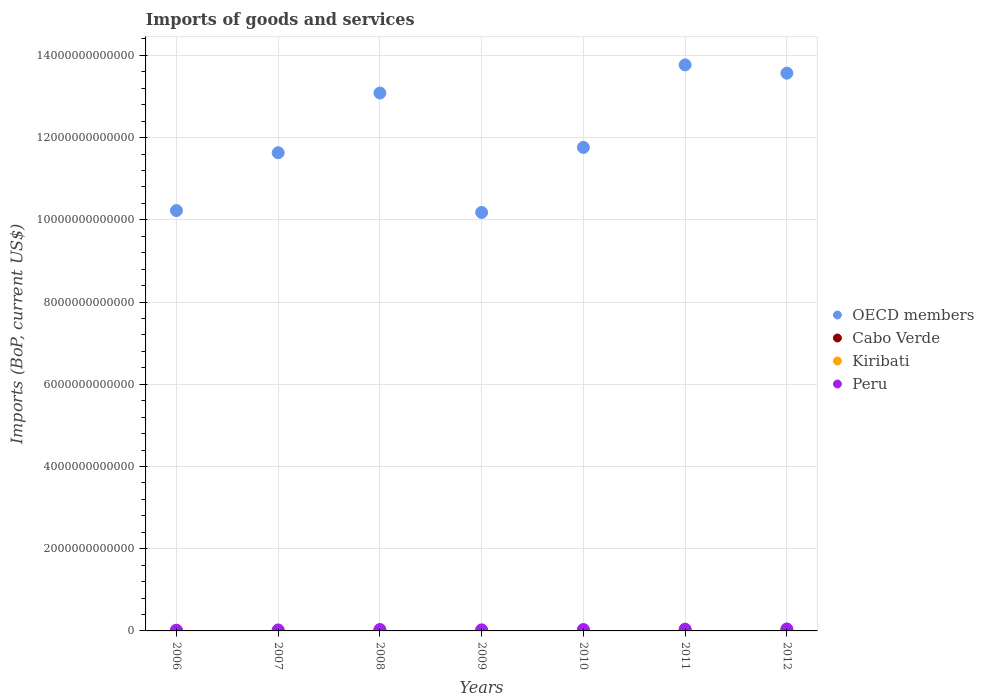Is the number of dotlines equal to the number of legend labels?
Your response must be concise. Yes. What is the amount spent on imports in Peru in 2012?
Offer a terse response. 4.77e+1. Across all years, what is the maximum amount spent on imports in OECD members?
Offer a terse response. 1.38e+13. Across all years, what is the minimum amount spent on imports in Peru?
Your answer should be compact. 1.79e+1. In which year was the amount spent on imports in Peru minimum?
Your answer should be compact. 2006. What is the total amount spent on imports in Kiribati in the graph?
Your answer should be very brief. 9.16e+08. What is the difference between the amount spent on imports in Cabo Verde in 2007 and that in 2010?
Provide a succinct answer. -8.03e+07. What is the difference between the amount spent on imports in Peru in 2010 and the amount spent on imports in OECD members in 2007?
Make the answer very short. -1.16e+13. What is the average amount spent on imports in Cabo Verde per year?
Your answer should be very brief. 1.11e+09. In the year 2010, what is the difference between the amount spent on imports in Cabo Verde and amount spent on imports in Kiribati?
Your response must be concise. 9.88e+08. What is the ratio of the amount spent on imports in OECD members in 2009 to that in 2010?
Provide a short and direct response. 0.87. What is the difference between the highest and the second highest amount spent on imports in OECD members?
Your answer should be compact. 2.02e+11. What is the difference between the highest and the lowest amount spent on imports in Cabo Verde?
Your answer should be compact. 5.70e+08. Is the sum of the amount spent on imports in OECD members in 2007 and 2011 greater than the maximum amount spent on imports in Cabo Verde across all years?
Offer a very short reply. Yes. Is it the case that in every year, the sum of the amount spent on imports in Peru and amount spent on imports in Cabo Verde  is greater than the sum of amount spent on imports in Kiribati and amount spent on imports in OECD members?
Offer a very short reply. Yes. How many dotlines are there?
Give a very brief answer. 4. What is the difference between two consecutive major ticks on the Y-axis?
Provide a short and direct response. 2.00e+12. Are the values on the major ticks of Y-axis written in scientific E-notation?
Keep it short and to the point. No. Does the graph contain any zero values?
Ensure brevity in your answer.  No. Where does the legend appear in the graph?
Make the answer very short. Center right. How are the legend labels stacked?
Your answer should be very brief. Vertical. What is the title of the graph?
Offer a very short reply. Imports of goods and services. What is the label or title of the Y-axis?
Your answer should be very brief. Imports (BoP, current US$). What is the Imports (BoP, current US$) of OECD members in 2006?
Your answer should be compact. 1.02e+13. What is the Imports (BoP, current US$) in Cabo Verde in 2006?
Make the answer very short. 8.04e+08. What is the Imports (BoP, current US$) in Kiribati in 2006?
Offer a very short reply. 9.63e+07. What is the Imports (BoP, current US$) of Peru in 2006?
Make the answer very short. 1.79e+1. What is the Imports (BoP, current US$) in OECD members in 2007?
Your response must be concise. 1.16e+13. What is the Imports (BoP, current US$) of Cabo Verde in 2007?
Your answer should be very brief. 1.03e+09. What is the Imports (BoP, current US$) in Kiribati in 2007?
Your answer should be very brief. 1.16e+08. What is the Imports (BoP, current US$) in Peru in 2007?
Provide a succinct answer. 2.36e+1. What is the Imports (BoP, current US$) in OECD members in 2008?
Your answer should be compact. 1.31e+13. What is the Imports (BoP, current US$) in Cabo Verde in 2008?
Offer a terse response. 1.18e+09. What is the Imports (BoP, current US$) in Kiribati in 2008?
Provide a short and direct response. 1.26e+08. What is the Imports (BoP, current US$) in Peru in 2008?
Make the answer very short. 3.38e+1. What is the Imports (BoP, current US$) of OECD members in 2009?
Ensure brevity in your answer.  1.02e+13. What is the Imports (BoP, current US$) of Cabo Verde in 2009?
Give a very brief answer. 1.08e+09. What is the Imports (BoP, current US$) in Kiribati in 2009?
Offer a terse response. 1.16e+08. What is the Imports (BoP, current US$) in Peru in 2009?
Ensure brevity in your answer.  2.56e+1. What is the Imports (BoP, current US$) in OECD members in 2010?
Your answer should be compact. 1.18e+13. What is the Imports (BoP, current US$) of Cabo Verde in 2010?
Offer a very short reply. 1.11e+09. What is the Imports (BoP, current US$) in Kiribati in 2010?
Provide a short and direct response. 1.26e+08. What is the Imports (BoP, current US$) in Peru in 2010?
Give a very brief answer. 3.44e+1. What is the Imports (BoP, current US$) in OECD members in 2011?
Provide a succinct answer. 1.38e+13. What is the Imports (BoP, current US$) in Cabo Verde in 2011?
Offer a terse response. 1.37e+09. What is the Imports (BoP, current US$) in Kiribati in 2011?
Provide a succinct answer. 1.56e+08. What is the Imports (BoP, current US$) of Peru in 2011?
Your answer should be compact. 4.30e+1. What is the Imports (BoP, current US$) of OECD members in 2012?
Give a very brief answer. 1.36e+13. What is the Imports (BoP, current US$) in Cabo Verde in 2012?
Provide a short and direct response. 1.19e+09. What is the Imports (BoP, current US$) of Kiribati in 2012?
Provide a short and direct response. 1.80e+08. What is the Imports (BoP, current US$) in Peru in 2012?
Offer a terse response. 4.77e+1. Across all years, what is the maximum Imports (BoP, current US$) in OECD members?
Your response must be concise. 1.38e+13. Across all years, what is the maximum Imports (BoP, current US$) in Cabo Verde?
Provide a succinct answer. 1.37e+09. Across all years, what is the maximum Imports (BoP, current US$) of Kiribati?
Give a very brief answer. 1.80e+08. Across all years, what is the maximum Imports (BoP, current US$) of Peru?
Ensure brevity in your answer.  4.77e+1. Across all years, what is the minimum Imports (BoP, current US$) of OECD members?
Keep it short and to the point. 1.02e+13. Across all years, what is the minimum Imports (BoP, current US$) in Cabo Verde?
Offer a very short reply. 8.04e+08. Across all years, what is the minimum Imports (BoP, current US$) in Kiribati?
Provide a succinct answer. 9.63e+07. Across all years, what is the minimum Imports (BoP, current US$) in Peru?
Offer a very short reply. 1.79e+1. What is the total Imports (BoP, current US$) in OECD members in the graph?
Offer a terse response. 8.42e+13. What is the total Imports (BoP, current US$) of Cabo Verde in the graph?
Ensure brevity in your answer.  7.78e+09. What is the total Imports (BoP, current US$) in Kiribati in the graph?
Keep it short and to the point. 9.16e+08. What is the total Imports (BoP, current US$) in Peru in the graph?
Give a very brief answer. 2.26e+11. What is the difference between the Imports (BoP, current US$) in OECD members in 2006 and that in 2007?
Offer a terse response. -1.41e+12. What is the difference between the Imports (BoP, current US$) of Cabo Verde in 2006 and that in 2007?
Provide a short and direct response. -2.30e+08. What is the difference between the Imports (BoP, current US$) of Kiribati in 2006 and that in 2007?
Keep it short and to the point. -1.95e+07. What is the difference between the Imports (BoP, current US$) in Peru in 2006 and that in 2007?
Keep it short and to the point. -5.74e+09. What is the difference between the Imports (BoP, current US$) of OECD members in 2006 and that in 2008?
Provide a short and direct response. -2.86e+12. What is the difference between the Imports (BoP, current US$) in Cabo Verde in 2006 and that in 2008?
Give a very brief answer. -3.79e+08. What is the difference between the Imports (BoP, current US$) in Kiribati in 2006 and that in 2008?
Your answer should be compact. -2.96e+07. What is the difference between the Imports (BoP, current US$) of Peru in 2006 and that in 2008?
Make the answer very short. -1.59e+1. What is the difference between the Imports (BoP, current US$) of OECD members in 2006 and that in 2009?
Your answer should be very brief. 4.54e+1. What is the difference between the Imports (BoP, current US$) in Cabo Verde in 2006 and that in 2009?
Give a very brief answer. -2.79e+08. What is the difference between the Imports (BoP, current US$) in Kiribati in 2006 and that in 2009?
Ensure brevity in your answer.  -1.99e+07. What is the difference between the Imports (BoP, current US$) in Peru in 2006 and that in 2009?
Offer a very short reply. -7.75e+09. What is the difference between the Imports (BoP, current US$) in OECD members in 2006 and that in 2010?
Ensure brevity in your answer.  -1.54e+12. What is the difference between the Imports (BoP, current US$) of Cabo Verde in 2006 and that in 2010?
Offer a terse response. -3.10e+08. What is the difference between the Imports (BoP, current US$) in Kiribati in 2006 and that in 2010?
Offer a terse response. -2.94e+07. What is the difference between the Imports (BoP, current US$) in Peru in 2006 and that in 2010?
Your answer should be compact. -1.66e+1. What is the difference between the Imports (BoP, current US$) in OECD members in 2006 and that in 2011?
Your answer should be compact. -3.54e+12. What is the difference between the Imports (BoP, current US$) in Cabo Verde in 2006 and that in 2011?
Provide a succinct answer. -5.70e+08. What is the difference between the Imports (BoP, current US$) in Kiribati in 2006 and that in 2011?
Your answer should be very brief. -5.98e+07. What is the difference between the Imports (BoP, current US$) in Peru in 2006 and that in 2011?
Ensure brevity in your answer.  -2.51e+1. What is the difference between the Imports (BoP, current US$) of OECD members in 2006 and that in 2012?
Provide a succinct answer. -3.34e+12. What is the difference between the Imports (BoP, current US$) of Cabo Verde in 2006 and that in 2012?
Ensure brevity in your answer.  -3.84e+08. What is the difference between the Imports (BoP, current US$) of Kiribati in 2006 and that in 2012?
Provide a succinct answer. -8.41e+07. What is the difference between the Imports (BoP, current US$) of Peru in 2006 and that in 2012?
Provide a succinct answer. -2.99e+1. What is the difference between the Imports (BoP, current US$) in OECD members in 2007 and that in 2008?
Your answer should be compact. -1.45e+12. What is the difference between the Imports (BoP, current US$) of Cabo Verde in 2007 and that in 2008?
Your answer should be very brief. -1.50e+08. What is the difference between the Imports (BoP, current US$) in Kiribati in 2007 and that in 2008?
Give a very brief answer. -1.01e+07. What is the difference between the Imports (BoP, current US$) in Peru in 2007 and that in 2008?
Your answer should be compact. -1.02e+1. What is the difference between the Imports (BoP, current US$) of OECD members in 2007 and that in 2009?
Ensure brevity in your answer.  1.45e+12. What is the difference between the Imports (BoP, current US$) in Cabo Verde in 2007 and that in 2009?
Keep it short and to the point. -4.92e+07. What is the difference between the Imports (BoP, current US$) in Kiribati in 2007 and that in 2009?
Provide a short and direct response. -4.05e+05. What is the difference between the Imports (BoP, current US$) of Peru in 2007 and that in 2009?
Your response must be concise. -2.01e+09. What is the difference between the Imports (BoP, current US$) of OECD members in 2007 and that in 2010?
Your answer should be compact. -1.30e+11. What is the difference between the Imports (BoP, current US$) in Cabo Verde in 2007 and that in 2010?
Provide a short and direct response. -8.03e+07. What is the difference between the Imports (BoP, current US$) in Kiribati in 2007 and that in 2010?
Ensure brevity in your answer.  -9.92e+06. What is the difference between the Imports (BoP, current US$) of Peru in 2007 and that in 2010?
Offer a very short reply. -1.08e+1. What is the difference between the Imports (BoP, current US$) in OECD members in 2007 and that in 2011?
Your response must be concise. -2.14e+12. What is the difference between the Imports (BoP, current US$) in Cabo Verde in 2007 and that in 2011?
Make the answer very short. -3.40e+08. What is the difference between the Imports (BoP, current US$) in Kiribati in 2007 and that in 2011?
Make the answer very short. -4.03e+07. What is the difference between the Imports (BoP, current US$) in Peru in 2007 and that in 2011?
Give a very brief answer. -1.93e+1. What is the difference between the Imports (BoP, current US$) of OECD members in 2007 and that in 2012?
Offer a terse response. -1.94e+12. What is the difference between the Imports (BoP, current US$) in Cabo Verde in 2007 and that in 2012?
Your answer should be compact. -1.54e+08. What is the difference between the Imports (BoP, current US$) of Kiribati in 2007 and that in 2012?
Ensure brevity in your answer.  -6.46e+07. What is the difference between the Imports (BoP, current US$) of Peru in 2007 and that in 2012?
Your answer should be very brief. -2.41e+1. What is the difference between the Imports (BoP, current US$) in OECD members in 2008 and that in 2009?
Offer a terse response. 2.90e+12. What is the difference between the Imports (BoP, current US$) in Cabo Verde in 2008 and that in 2009?
Provide a succinct answer. 1.00e+08. What is the difference between the Imports (BoP, current US$) in Kiribati in 2008 and that in 2009?
Your answer should be compact. 9.73e+06. What is the difference between the Imports (BoP, current US$) in Peru in 2008 and that in 2009?
Provide a succinct answer. 8.17e+09. What is the difference between the Imports (BoP, current US$) in OECD members in 2008 and that in 2010?
Ensure brevity in your answer.  1.32e+12. What is the difference between the Imports (BoP, current US$) of Cabo Verde in 2008 and that in 2010?
Give a very brief answer. 6.93e+07. What is the difference between the Imports (BoP, current US$) in Kiribati in 2008 and that in 2010?
Your response must be concise. 2.10e+05. What is the difference between the Imports (BoP, current US$) of Peru in 2008 and that in 2010?
Give a very brief answer. -6.41e+08. What is the difference between the Imports (BoP, current US$) of OECD members in 2008 and that in 2011?
Provide a succinct answer. -6.85e+11. What is the difference between the Imports (BoP, current US$) in Cabo Verde in 2008 and that in 2011?
Your response must be concise. -1.90e+08. What is the difference between the Imports (BoP, current US$) in Kiribati in 2008 and that in 2011?
Offer a very short reply. -3.02e+07. What is the difference between the Imports (BoP, current US$) of Peru in 2008 and that in 2011?
Your response must be concise. -9.17e+09. What is the difference between the Imports (BoP, current US$) in OECD members in 2008 and that in 2012?
Make the answer very short. -4.83e+11. What is the difference between the Imports (BoP, current US$) of Cabo Verde in 2008 and that in 2012?
Your answer should be very brief. -4.40e+06. What is the difference between the Imports (BoP, current US$) of Kiribati in 2008 and that in 2012?
Provide a short and direct response. -5.44e+07. What is the difference between the Imports (BoP, current US$) in Peru in 2008 and that in 2012?
Your answer should be very brief. -1.39e+1. What is the difference between the Imports (BoP, current US$) in OECD members in 2009 and that in 2010?
Offer a terse response. -1.58e+12. What is the difference between the Imports (BoP, current US$) in Cabo Verde in 2009 and that in 2010?
Keep it short and to the point. -3.11e+07. What is the difference between the Imports (BoP, current US$) of Kiribati in 2009 and that in 2010?
Provide a short and direct response. -9.52e+06. What is the difference between the Imports (BoP, current US$) of Peru in 2009 and that in 2010?
Your response must be concise. -8.81e+09. What is the difference between the Imports (BoP, current US$) in OECD members in 2009 and that in 2011?
Give a very brief answer. -3.59e+12. What is the difference between the Imports (BoP, current US$) of Cabo Verde in 2009 and that in 2011?
Offer a very short reply. -2.91e+08. What is the difference between the Imports (BoP, current US$) of Kiribati in 2009 and that in 2011?
Ensure brevity in your answer.  -3.99e+07. What is the difference between the Imports (BoP, current US$) in Peru in 2009 and that in 2011?
Keep it short and to the point. -1.73e+1. What is the difference between the Imports (BoP, current US$) in OECD members in 2009 and that in 2012?
Ensure brevity in your answer.  -3.39e+12. What is the difference between the Imports (BoP, current US$) of Cabo Verde in 2009 and that in 2012?
Offer a terse response. -1.05e+08. What is the difference between the Imports (BoP, current US$) in Kiribati in 2009 and that in 2012?
Provide a short and direct response. -6.42e+07. What is the difference between the Imports (BoP, current US$) of Peru in 2009 and that in 2012?
Your answer should be very brief. -2.21e+1. What is the difference between the Imports (BoP, current US$) in OECD members in 2010 and that in 2011?
Your response must be concise. -2.01e+12. What is the difference between the Imports (BoP, current US$) of Cabo Verde in 2010 and that in 2011?
Ensure brevity in your answer.  -2.60e+08. What is the difference between the Imports (BoP, current US$) in Kiribati in 2010 and that in 2011?
Ensure brevity in your answer.  -3.04e+07. What is the difference between the Imports (BoP, current US$) of Peru in 2010 and that in 2011?
Give a very brief answer. -8.53e+09. What is the difference between the Imports (BoP, current US$) in OECD members in 2010 and that in 2012?
Ensure brevity in your answer.  -1.81e+12. What is the difference between the Imports (BoP, current US$) in Cabo Verde in 2010 and that in 2012?
Your answer should be compact. -7.37e+07. What is the difference between the Imports (BoP, current US$) of Kiribati in 2010 and that in 2012?
Keep it short and to the point. -5.46e+07. What is the difference between the Imports (BoP, current US$) of Peru in 2010 and that in 2012?
Give a very brief answer. -1.33e+1. What is the difference between the Imports (BoP, current US$) in OECD members in 2011 and that in 2012?
Provide a short and direct response. 2.02e+11. What is the difference between the Imports (BoP, current US$) in Cabo Verde in 2011 and that in 2012?
Ensure brevity in your answer.  1.86e+08. What is the difference between the Imports (BoP, current US$) of Kiribati in 2011 and that in 2012?
Ensure brevity in your answer.  -2.43e+07. What is the difference between the Imports (BoP, current US$) of Peru in 2011 and that in 2012?
Your answer should be very brief. -4.77e+09. What is the difference between the Imports (BoP, current US$) in OECD members in 2006 and the Imports (BoP, current US$) in Cabo Verde in 2007?
Offer a very short reply. 1.02e+13. What is the difference between the Imports (BoP, current US$) in OECD members in 2006 and the Imports (BoP, current US$) in Kiribati in 2007?
Your answer should be very brief. 1.02e+13. What is the difference between the Imports (BoP, current US$) in OECD members in 2006 and the Imports (BoP, current US$) in Peru in 2007?
Keep it short and to the point. 1.02e+13. What is the difference between the Imports (BoP, current US$) in Cabo Verde in 2006 and the Imports (BoP, current US$) in Kiribati in 2007?
Provide a short and direct response. 6.88e+08. What is the difference between the Imports (BoP, current US$) in Cabo Verde in 2006 and the Imports (BoP, current US$) in Peru in 2007?
Provide a short and direct response. -2.28e+1. What is the difference between the Imports (BoP, current US$) in Kiribati in 2006 and the Imports (BoP, current US$) in Peru in 2007?
Your answer should be very brief. -2.35e+1. What is the difference between the Imports (BoP, current US$) of OECD members in 2006 and the Imports (BoP, current US$) of Cabo Verde in 2008?
Your answer should be compact. 1.02e+13. What is the difference between the Imports (BoP, current US$) in OECD members in 2006 and the Imports (BoP, current US$) in Kiribati in 2008?
Provide a short and direct response. 1.02e+13. What is the difference between the Imports (BoP, current US$) in OECD members in 2006 and the Imports (BoP, current US$) in Peru in 2008?
Offer a terse response. 1.02e+13. What is the difference between the Imports (BoP, current US$) of Cabo Verde in 2006 and the Imports (BoP, current US$) of Kiribati in 2008?
Offer a very short reply. 6.78e+08. What is the difference between the Imports (BoP, current US$) in Cabo Verde in 2006 and the Imports (BoP, current US$) in Peru in 2008?
Keep it short and to the point. -3.30e+1. What is the difference between the Imports (BoP, current US$) in Kiribati in 2006 and the Imports (BoP, current US$) in Peru in 2008?
Offer a terse response. -3.37e+1. What is the difference between the Imports (BoP, current US$) in OECD members in 2006 and the Imports (BoP, current US$) in Cabo Verde in 2009?
Your answer should be compact. 1.02e+13. What is the difference between the Imports (BoP, current US$) in OECD members in 2006 and the Imports (BoP, current US$) in Kiribati in 2009?
Your answer should be compact. 1.02e+13. What is the difference between the Imports (BoP, current US$) of OECD members in 2006 and the Imports (BoP, current US$) of Peru in 2009?
Your answer should be very brief. 1.02e+13. What is the difference between the Imports (BoP, current US$) of Cabo Verde in 2006 and the Imports (BoP, current US$) of Kiribati in 2009?
Keep it short and to the point. 6.88e+08. What is the difference between the Imports (BoP, current US$) in Cabo Verde in 2006 and the Imports (BoP, current US$) in Peru in 2009?
Offer a terse response. -2.48e+1. What is the difference between the Imports (BoP, current US$) in Kiribati in 2006 and the Imports (BoP, current US$) in Peru in 2009?
Your answer should be very brief. -2.55e+1. What is the difference between the Imports (BoP, current US$) of OECD members in 2006 and the Imports (BoP, current US$) of Cabo Verde in 2010?
Ensure brevity in your answer.  1.02e+13. What is the difference between the Imports (BoP, current US$) of OECD members in 2006 and the Imports (BoP, current US$) of Kiribati in 2010?
Your answer should be compact. 1.02e+13. What is the difference between the Imports (BoP, current US$) in OECD members in 2006 and the Imports (BoP, current US$) in Peru in 2010?
Give a very brief answer. 1.02e+13. What is the difference between the Imports (BoP, current US$) of Cabo Verde in 2006 and the Imports (BoP, current US$) of Kiribati in 2010?
Make the answer very short. 6.78e+08. What is the difference between the Imports (BoP, current US$) in Cabo Verde in 2006 and the Imports (BoP, current US$) in Peru in 2010?
Provide a succinct answer. -3.36e+1. What is the difference between the Imports (BoP, current US$) of Kiribati in 2006 and the Imports (BoP, current US$) of Peru in 2010?
Offer a terse response. -3.43e+1. What is the difference between the Imports (BoP, current US$) in OECD members in 2006 and the Imports (BoP, current US$) in Cabo Verde in 2011?
Provide a succinct answer. 1.02e+13. What is the difference between the Imports (BoP, current US$) of OECD members in 2006 and the Imports (BoP, current US$) of Kiribati in 2011?
Give a very brief answer. 1.02e+13. What is the difference between the Imports (BoP, current US$) of OECD members in 2006 and the Imports (BoP, current US$) of Peru in 2011?
Ensure brevity in your answer.  1.02e+13. What is the difference between the Imports (BoP, current US$) in Cabo Verde in 2006 and the Imports (BoP, current US$) in Kiribati in 2011?
Your answer should be compact. 6.48e+08. What is the difference between the Imports (BoP, current US$) of Cabo Verde in 2006 and the Imports (BoP, current US$) of Peru in 2011?
Your response must be concise. -4.22e+1. What is the difference between the Imports (BoP, current US$) of Kiribati in 2006 and the Imports (BoP, current US$) of Peru in 2011?
Your answer should be compact. -4.29e+1. What is the difference between the Imports (BoP, current US$) in OECD members in 2006 and the Imports (BoP, current US$) in Cabo Verde in 2012?
Offer a very short reply. 1.02e+13. What is the difference between the Imports (BoP, current US$) in OECD members in 2006 and the Imports (BoP, current US$) in Kiribati in 2012?
Ensure brevity in your answer.  1.02e+13. What is the difference between the Imports (BoP, current US$) in OECD members in 2006 and the Imports (BoP, current US$) in Peru in 2012?
Give a very brief answer. 1.02e+13. What is the difference between the Imports (BoP, current US$) in Cabo Verde in 2006 and the Imports (BoP, current US$) in Kiribati in 2012?
Your answer should be very brief. 6.23e+08. What is the difference between the Imports (BoP, current US$) of Cabo Verde in 2006 and the Imports (BoP, current US$) of Peru in 2012?
Your answer should be very brief. -4.69e+1. What is the difference between the Imports (BoP, current US$) in Kiribati in 2006 and the Imports (BoP, current US$) in Peru in 2012?
Provide a short and direct response. -4.76e+1. What is the difference between the Imports (BoP, current US$) of OECD members in 2007 and the Imports (BoP, current US$) of Cabo Verde in 2008?
Your response must be concise. 1.16e+13. What is the difference between the Imports (BoP, current US$) in OECD members in 2007 and the Imports (BoP, current US$) in Kiribati in 2008?
Your response must be concise. 1.16e+13. What is the difference between the Imports (BoP, current US$) of OECD members in 2007 and the Imports (BoP, current US$) of Peru in 2008?
Offer a very short reply. 1.16e+13. What is the difference between the Imports (BoP, current US$) in Cabo Verde in 2007 and the Imports (BoP, current US$) in Kiribati in 2008?
Give a very brief answer. 9.08e+08. What is the difference between the Imports (BoP, current US$) in Cabo Verde in 2007 and the Imports (BoP, current US$) in Peru in 2008?
Keep it short and to the point. -3.28e+1. What is the difference between the Imports (BoP, current US$) in Kiribati in 2007 and the Imports (BoP, current US$) in Peru in 2008?
Keep it short and to the point. -3.37e+1. What is the difference between the Imports (BoP, current US$) in OECD members in 2007 and the Imports (BoP, current US$) in Cabo Verde in 2009?
Your response must be concise. 1.16e+13. What is the difference between the Imports (BoP, current US$) of OECD members in 2007 and the Imports (BoP, current US$) of Kiribati in 2009?
Provide a short and direct response. 1.16e+13. What is the difference between the Imports (BoP, current US$) in OECD members in 2007 and the Imports (BoP, current US$) in Peru in 2009?
Provide a succinct answer. 1.16e+13. What is the difference between the Imports (BoP, current US$) in Cabo Verde in 2007 and the Imports (BoP, current US$) in Kiribati in 2009?
Give a very brief answer. 9.17e+08. What is the difference between the Imports (BoP, current US$) of Cabo Verde in 2007 and the Imports (BoP, current US$) of Peru in 2009?
Your answer should be compact. -2.46e+1. What is the difference between the Imports (BoP, current US$) in Kiribati in 2007 and the Imports (BoP, current US$) in Peru in 2009?
Keep it short and to the point. -2.55e+1. What is the difference between the Imports (BoP, current US$) of OECD members in 2007 and the Imports (BoP, current US$) of Cabo Verde in 2010?
Keep it short and to the point. 1.16e+13. What is the difference between the Imports (BoP, current US$) of OECD members in 2007 and the Imports (BoP, current US$) of Kiribati in 2010?
Provide a short and direct response. 1.16e+13. What is the difference between the Imports (BoP, current US$) of OECD members in 2007 and the Imports (BoP, current US$) of Peru in 2010?
Your answer should be compact. 1.16e+13. What is the difference between the Imports (BoP, current US$) in Cabo Verde in 2007 and the Imports (BoP, current US$) in Kiribati in 2010?
Provide a succinct answer. 9.08e+08. What is the difference between the Imports (BoP, current US$) of Cabo Verde in 2007 and the Imports (BoP, current US$) of Peru in 2010?
Keep it short and to the point. -3.34e+1. What is the difference between the Imports (BoP, current US$) in Kiribati in 2007 and the Imports (BoP, current US$) in Peru in 2010?
Offer a very short reply. -3.43e+1. What is the difference between the Imports (BoP, current US$) of OECD members in 2007 and the Imports (BoP, current US$) of Cabo Verde in 2011?
Your response must be concise. 1.16e+13. What is the difference between the Imports (BoP, current US$) of OECD members in 2007 and the Imports (BoP, current US$) of Kiribati in 2011?
Your response must be concise. 1.16e+13. What is the difference between the Imports (BoP, current US$) of OECD members in 2007 and the Imports (BoP, current US$) of Peru in 2011?
Your answer should be very brief. 1.16e+13. What is the difference between the Imports (BoP, current US$) in Cabo Verde in 2007 and the Imports (BoP, current US$) in Kiribati in 2011?
Provide a short and direct response. 8.77e+08. What is the difference between the Imports (BoP, current US$) of Cabo Verde in 2007 and the Imports (BoP, current US$) of Peru in 2011?
Make the answer very short. -4.19e+1. What is the difference between the Imports (BoP, current US$) in Kiribati in 2007 and the Imports (BoP, current US$) in Peru in 2011?
Offer a terse response. -4.28e+1. What is the difference between the Imports (BoP, current US$) in OECD members in 2007 and the Imports (BoP, current US$) in Cabo Verde in 2012?
Keep it short and to the point. 1.16e+13. What is the difference between the Imports (BoP, current US$) of OECD members in 2007 and the Imports (BoP, current US$) of Kiribati in 2012?
Give a very brief answer. 1.16e+13. What is the difference between the Imports (BoP, current US$) of OECD members in 2007 and the Imports (BoP, current US$) of Peru in 2012?
Make the answer very short. 1.16e+13. What is the difference between the Imports (BoP, current US$) of Cabo Verde in 2007 and the Imports (BoP, current US$) of Kiribati in 2012?
Make the answer very short. 8.53e+08. What is the difference between the Imports (BoP, current US$) of Cabo Verde in 2007 and the Imports (BoP, current US$) of Peru in 2012?
Offer a terse response. -4.67e+1. What is the difference between the Imports (BoP, current US$) of Kiribati in 2007 and the Imports (BoP, current US$) of Peru in 2012?
Provide a succinct answer. -4.76e+1. What is the difference between the Imports (BoP, current US$) in OECD members in 2008 and the Imports (BoP, current US$) in Cabo Verde in 2009?
Ensure brevity in your answer.  1.31e+13. What is the difference between the Imports (BoP, current US$) in OECD members in 2008 and the Imports (BoP, current US$) in Kiribati in 2009?
Provide a short and direct response. 1.31e+13. What is the difference between the Imports (BoP, current US$) in OECD members in 2008 and the Imports (BoP, current US$) in Peru in 2009?
Keep it short and to the point. 1.31e+13. What is the difference between the Imports (BoP, current US$) of Cabo Verde in 2008 and the Imports (BoP, current US$) of Kiribati in 2009?
Your answer should be very brief. 1.07e+09. What is the difference between the Imports (BoP, current US$) of Cabo Verde in 2008 and the Imports (BoP, current US$) of Peru in 2009?
Your answer should be compact. -2.44e+1. What is the difference between the Imports (BoP, current US$) in Kiribati in 2008 and the Imports (BoP, current US$) in Peru in 2009?
Offer a very short reply. -2.55e+1. What is the difference between the Imports (BoP, current US$) of OECD members in 2008 and the Imports (BoP, current US$) of Cabo Verde in 2010?
Your response must be concise. 1.31e+13. What is the difference between the Imports (BoP, current US$) in OECD members in 2008 and the Imports (BoP, current US$) in Kiribati in 2010?
Offer a very short reply. 1.31e+13. What is the difference between the Imports (BoP, current US$) of OECD members in 2008 and the Imports (BoP, current US$) of Peru in 2010?
Give a very brief answer. 1.31e+13. What is the difference between the Imports (BoP, current US$) in Cabo Verde in 2008 and the Imports (BoP, current US$) in Kiribati in 2010?
Offer a terse response. 1.06e+09. What is the difference between the Imports (BoP, current US$) in Cabo Verde in 2008 and the Imports (BoP, current US$) in Peru in 2010?
Your response must be concise. -3.33e+1. What is the difference between the Imports (BoP, current US$) in Kiribati in 2008 and the Imports (BoP, current US$) in Peru in 2010?
Provide a succinct answer. -3.43e+1. What is the difference between the Imports (BoP, current US$) in OECD members in 2008 and the Imports (BoP, current US$) in Cabo Verde in 2011?
Ensure brevity in your answer.  1.31e+13. What is the difference between the Imports (BoP, current US$) of OECD members in 2008 and the Imports (BoP, current US$) of Kiribati in 2011?
Your answer should be compact. 1.31e+13. What is the difference between the Imports (BoP, current US$) in OECD members in 2008 and the Imports (BoP, current US$) in Peru in 2011?
Your response must be concise. 1.30e+13. What is the difference between the Imports (BoP, current US$) of Cabo Verde in 2008 and the Imports (BoP, current US$) of Kiribati in 2011?
Your answer should be very brief. 1.03e+09. What is the difference between the Imports (BoP, current US$) of Cabo Verde in 2008 and the Imports (BoP, current US$) of Peru in 2011?
Give a very brief answer. -4.18e+1. What is the difference between the Imports (BoP, current US$) in Kiribati in 2008 and the Imports (BoP, current US$) in Peru in 2011?
Your response must be concise. -4.28e+1. What is the difference between the Imports (BoP, current US$) in OECD members in 2008 and the Imports (BoP, current US$) in Cabo Verde in 2012?
Offer a very short reply. 1.31e+13. What is the difference between the Imports (BoP, current US$) of OECD members in 2008 and the Imports (BoP, current US$) of Kiribati in 2012?
Your answer should be compact. 1.31e+13. What is the difference between the Imports (BoP, current US$) in OECD members in 2008 and the Imports (BoP, current US$) in Peru in 2012?
Keep it short and to the point. 1.30e+13. What is the difference between the Imports (BoP, current US$) of Cabo Verde in 2008 and the Imports (BoP, current US$) of Kiribati in 2012?
Provide a short and direct response. 1.00e+09. What is the difference between the Imports (BoP, current US$) in Cabo Verde in 2008 and the Imports (BoP, current US$) in Peru in 2012?
Make the answer very short. -4.66e+1. What is the difference between the Imports (BoP, current US$) of Kiribati in 2008 and the Imports (BoP, current US$) of Peru in 2012?
Offer a very short reply. -4.76e+1. What is the difference between the Imports (BoP, current US$) of OECD members in 2009 and the Imports (BoP, current US$) of Cabo Verde in 2010?
Make the answer very short. 1.02e+13. What is the difference between the Imports (BoP, current US$) of OECD members in 2009 and the Imports (BoP, current US$) of Kiribati in 2010?
Your response must be concise. 1.02e+13. What is the difference between the Imports (BoP, current US$) in OECD members in 2009 and the Imports (BoP, current US$) in Peru in 2010?
Offer a very short reply. 1.01e+13. What is the difference between the Imports (BoP, current US$) in Cabo Verde in 2009 and the Imports (BoP, current US$) in Kiribati in 2010?
Offer a terse response. 9.57e+08. What is the difference between the Imports (BoP, current US$) of Cabo Verde in 2009 and the Imports (BoP, current US$) of Peru in 2010?
Provide a short and direct response. -3.34e+1. What is the difference between the Imports (BoP, current US$) of Kiribati in 2009 and the Imports (BoP, current US$) of Peru in 2010?
Keep it short and to the point. -3.43e+1. What is the difference between the Imports (BoP, current US$) of OECD members in 2009 and the Imports (BoP, current US$) of Cabo Verde in 2011?
Your answer should be very brief. 1.02e+13. What is the difference between the Imports (BoP, current US$) in OECD members in 2009 and the Imports (BoP, current US$) in Kiribati in 2011?
Ensure brevity in your answer.  1.02e+13. What is the difference between the Imports (BoP, current US$) in OECD members in 2009 and the Imports (BoP, current US$) in Peru in 2011?
Make the answer very short. 1.01e+13. What is the difference between the Imports (BoP, current US$) in Cabo Verde in 2009 and the Imports (BoP, current US$) in Kiribati in 2011?
Provide a succinct answer. 9.27e+08. What is the difference between the Imports (BoP, current US$) of Cabo Verde in 2009 and the Imports (BoP, current US$) of Peru in 2011?
Provide a succinct answer. -4.19e+1. What is the difference between the Imports (BoP, current US$) in Kiribati in 2009 and the Imports (BoP, current US$) in Peru in 2011?
Give a very brief answer. -4.28e+1. What is the difference between the Imports (BoP, current US$) in OECD members in 2009 and the Imports (BoP, current US$) in Cabo Verde in 2012?
Provide a succinct answer. 1.02e+13. What is the difference between the Imports (BoP, current US$) in OECD members in 2009 and the Imports (BoP, current US$) in Kiribati in 2012?
Ensure brevity in your answer.  1.02e+13. What is the difference between the Imports (BoP, current US$) of OECD members in 2009 and the Imports (BoP, current US$) of Peru in 2012?
Ensure brevity in your answer.  1.01e+13. What is the difference between the Imports (BoP, current US$) in Cabo Verde in 2009 and the Imports (BoP, current US$) in Kiribati in 2012?
Your response must be concise. 9.02e+08. What is the difference between the Imports (BoP, current US$) of Cabo Verde in 2009 and the Imports (BoP, current US$) of Peru in 2012?
Your response must be concise. -4.67e+1. What is the difference between the Imports (BoP, current US$) in Kiribati in 2009 and the Imports (BoP, current US$) in Peru in 2012?
Provide a short and direct response. -4.76e+1. What is the difference between the Imports (BoP, current US$) of OECD members in 2010 and the Imports (BoP, current US$) of Cabo Verde in 2011?
Offer a very short reply. 1.18e+13. What is the difference between the Imports (BoP, current US$) of OECD members in 2010 and the Imports (BoP, current US$) of Kiribati in 2011?
Make the answer very short. 1.18e+13. What is the difference between the Imports (BoP, current US$) of OECD members in 2010 and the Imports (BoP, current US$) of Peru in 2011?
Offer a very short reply. 1.17e+13. What is the difference between the Imports (BoP, current US$) of Cabo Verde in 2010 and the Imports (BoP, current US$) of Kiribati in 2011?
Offer a very short reply. 9.58e+08. What is the difference between the Imports (BoP, current US$) in Cabo Verde in 2010 and the Imports (BoP, current US$) in Peru in 2011?
Provide a succinct answer. -4.18e+1. What is the difference between the Imports (BoP, current US$) in Kiribati in 2010 and the Imports (BoP, current US$) in Peru in 2011?
Make the answer very short. -4.28e+1. What is the difference between the Imports (BoP, current US$) of OECD members in 2010 and the Imports (BoP, current US$) of Cabo Verde in 2012?
Ensure brevity in your answer.  1.18e+13. What is the difference between the Imports (BoP, current US$) in OECD members in 2010 and the Imports (BoP, current US$) in Kiribati in 2012?
Provide a short and direct response. 1.18e+13. What is the difference between the Imports (BoP, current US$) of OECD members in 2010 and the Imports (BoP, current US$) of Peru in 2012?
Offer a very short reply. 1.17e+13. What is the difference between the Imports (BoP, current US$) of Cabo Verde in 2010 and the Imports (BoP, current US$) of Kiribati in 2012?
Provide a succinct answer. 9.33e+08. What is the difference between the Imports (BoP, current US$) in Cabo Verde in 2010 and the Imports (BoP, current US$) in Peru in 2012?
Offer a very short reply. -4.66e+1. What is the difference between the Imports (BoP, current US$) of Kiribati in 2010 and the Imports (BoP, current US$) of Peru in 2012?
Offer a terse response. -4.76e+1. What is the difference between the Imports (BoP, current US$) in OECD members in 2011 and the Imports (BoP, current US$) in Cabo Verde in 2012?
Your response must be concise. 1.38e+13. What is the difference between the Imports (BoP, current US$) of OECD members in 2011 and the Imports (BoP, current US$) of Kiribati in 2012?
Make the answer very short. 1.38e+13. What is the difference between the Imports (BoP, current US$) in OECD members in 2011 and the Imports (BoP, current US$) in Peru in 2012?
Offer a terse response. 1.37e+13. What is the difference between the Imports (BoP, current US$) in Cabo Verde in 2011 and the Imports (BoP, current US$) in Kiribati in 2012?
Make the answer very short. 1.19e+09. What is the difference between the Imports (BoP, current US$) in Cabo Verde in 2011 and the Imports (BoP, current US$) in Peru in 2012?
Ensure brevity in your answer.  -4.64e+1. What is the difference between the Imports (BoP, current US$) in Kiribati in 2011 and the Imports (BoP, current US$) in Peru in 2012?
Ensure brevity in your answer.  -4.76e+1. What is the average Imports (BoP, current US$) of OECD members per year?
Your answer should be compact. 1.20e+13. What is the average Imports (BoP, current US$) of Cabo Verde per year?
Your answer should be very brief. 1.11e+09. What is the average Imports (BoP, current US$) in Kiribati per year?
Offer a terse response. 1.31e+08. What is the average Imports (BoP, current US$) in Peru per year?
Your response must be concise. 3.23e+1. In the year 2006, what is the difference between the Imports (BoP, current US$) of OECD members and Imports (BoP, current US$) of Cabo Verde?
Your answer should be compact. 1.02e+13. In the year 2006, what is the difference between the Imports (BoP, current US$) of OECD members and Imports (BoP, current US$) of Kiribati?
Your answer should be very brief. 1.02e+13. In the year 2006, what is the difference between the Imports (BoP, current US$) in OECD members and Imports (BoP, current US$) in Peru?
Provide a succinct answer. 1.02e+13. In the year 2006, what is the difference between the Imports (BoP, current US$) of Cabo Verde and Imports (BoP, current US$) of Kiribati?
Provide a succinct answer. 7.08e+08. In the year 2006, what is the difference between the Imports (BoP, current US$) of Cabo Verde and Imports (BoP, current US$) of Peru?
Give a very brief answer. -1.71e+1. In the year 2006, what is the difference between the Imports (BoP, current US$) of Kiribati and Imports (BoP, current US$) of Peru?
Offer a terse response. -1.78e+1. In the year 2007, what is the difference between the Imports (BoP, current US$) in OECD members and Imports (BoP, current US$) in Cabo Verde?
Ensure brevity in your answer.  1.16e+13. In the year 2007, what is the difference between the Imports (BoP, current US$) in OECD members and Imports (BoP, current US$) in Kiribati?
Provide a succinct answer. 1.16e+13. In the year 2007, what is the difference between the Imports (BoP, current US$) in OECD members and Imports (BoP, current US$) in Peru?
Ensure brevity in your answer.  1.16e+13. In the year 2007, what is the difference between the Imports (BoP, current US$) of Cabo Verde and Imports (BoP, current US$) of Kiribati?
Keep it short and to the point. 9.18e+08. In the year 2007, what is the difference between the Imports (BoP, current US$) of Cabo Verde and Imports (BoP, current US$) of Peru?
Make the answer very short. -2.26e+1. In the year 2007, what is the difference between the Imports (BoP, current US$) of Kiribati and Imports (BoP, current US$) of Peru?
Offer a terse response. -2.35e+1. In the year 2008, what is the difference between the Imports (BoP, current US$) of OECD members and Imports (BoP, current US$) of Cabo Verde?
Your response must be concise. 1.31e+13. In the year 2008, what is the difference between the Imports (BoP, current US$) in OECD members and Imports (BoP, current US$) in Kiribati?
Give a very brief answer. 1.31e+13. In the year 2008, what is the difference between the Imports (BoP, current US$) in OECD members and Imports (BoP, current US$) in Peru?
Offer a terse response. 1.31e+13. In the year 2008, what is the difference between the Imports (BoP, current US$) in Cabo Verde and Imports (BoP, current US$) in Kiribati?
Your answer should be compact. 1.06e+09. In the year 2008, what is the difference between the Imports (BoP, current US$) in Cabo Verde and Imports (BoP, current US$) in Peru?
Make the answer very short. -3.26e+1. In the year 2008, what is the difference between the Imports (BoP, current US$) of Kiribati and Imports (BoP, current US$) of Peru?
Give a very brief answer. -3.37e+1. In the year 2009, what is the difference between the Imports (BoP, current US$) of OECD members and Imports (BoP, current US$) of Cabo Verde?
Give a very brief answer. 1.02e+13. In the year 2009, what is the difference between the Imports (BoP, current US$) in OECD members and Imports (BoP, current US$) in Kiribati?
Offer a very short reply. 1.02e+13. In the year 2009, what is the difference between the Imports (BoP, current US$) of OECD members and Imports (BoP, current US$) of Peru?
Offer a very short reply. 1.02e+13. In the year 2009, what is the difference between the Imports (BoP, current US$) in Cabo Verde and Imports (BoP, current US$) in Kiribati?
Give a very brief answer. 9.67e+08. In the year 2009, what is the difference between the Imports (BoP, current US$) of Cabo Verde and Imports (BoP, current US$) of Peru?
Give a very brief answer. -2.45e+1. In the year 2009, what is the difference between the Imports (BoP, current US$) of Kiribati and Imports (BoP, current US$) of Peru?
Offer a terse response. -2.55e+1. In the year 2010, what is the difference between the Imports (BoP, current US$) in OECD members and Imports (BoP, current US$) in Cabo Verde?
Ensure brevity in your answer.  1.18e+13. In the year 2010, what is the difference between the Imports (BoP, current US$) of OECD members and Imports (BoP, current US$) of Kiribati?
Your response must be concise. 1.18e+13. In the year 2010, what is the difference between the Imports (BoP, current US$) in OECD members and Imports (BoP, current US$) in Peru?
Offer a very short reply. 1.17e+13. In the year 2010, what is the difference between the Imports (BoP, current US$) of Cabo Verde and Imports (BoP, current US$) of Kiribati?
Make the answer very short. 9.88e+08. In the year 2010, what is the difference between the Imports (BoP, current US$) of Cabo Verde and Imports (BoP, current US$) of Peru?
Your response must be concise. -3.33e+1. In the year 2010, what is the difference between the Imports (BoP, current US$) of Kiribati and Imports (BoP, current US$) of Peru?
Offer a terse response. -3.43e+1. In the year 2011, what is the difference between the Imports (BoP, current US$) of OECD members and Imports (BoP, current US$) of Cabo Verde?
Make the answer very short. 1.38e+13. In the year 2011, what is the difference between the Imports (BoP, current US$) in OECD members and Imports (BoP, current US$) in Kiribati?
Make the answer very short. 1.38e+13. In the year 2011, what is the difference between the Imports (BoP, current US$) of OECD members and Imports (BoP, current US$) of Peru?
Your response must be concise. 1.37e+13. In the year 2011, what is the difference between the Imports (BoP, current US$) of Cabo Verde and Imports (BoP, current US$) of Kiribati?
Give a very brief answer. 1.22e+09. In the year 2011, what is the difference between the Imports (BoP, current US$) of Cabo Verde and Imports (BoP, current US$) of Peru?
Provide a succinct answer. -4.16e+1. In the year 2011, what is the difference between the Imports (BoP, current US$) in Kiribati and Imports (BoP, current US$) in Peru?
Keep it short and to the point. -4.28e+1. In the year 2012, what is the difference between the Imports (BoP, current US$) of OECD members and Imports (BoP, current US$) of Cabo Verde?
Your response must be concise. 1.36e+13. In the year 2012, what is the difference between the Imports (BoP, current US$) of OECD members and Imports (BoP, current US$) of Kiribati?
Your response must be concise. 1.36e+13. In the year 2012, what is the difference between the Imports (BoP, current US$) in OECD members and Imports (BoP, current US$) in Peru?
Provide a short and direct response. 1.35e+13. In the year 2012, what is the difference between the Imports (BoP, current US$) of Cabo Verde and Imports (BoP, current US$) of Kiribati?
Make the answer very short. 1.01e+09. In the year 2012, what is the difference between the Imports (BoP, current US$) of Cabo Verde and Imports (BoP, current US$) of Peru?
Offer a terse response. -4.65e+1. In the year 2012, what is the difference between the Imports (BoP, current US$) in Kiribati and Imports (BoP, current US$) in Peru?
Your answer should be compact. -4.76e+1. What is the ratio of the Imports (BoP, current US$) in OECD members in 2006 to that in 2007?
Give a very brief answer. 0.88. What is the ratio of the Imports (BoP, current US$) in Kiribati in 2006 to that in 2007?
Keep it short and to the point. 0.83. What is the ratio of the Imports (BoP, current US$) of Peru in 2006 to that in 2007?
Make the answer very short. 0.76. What is the ratio of the Imports (BoP, current US$) of OECD members in 2006 to that in 2008?
Offer a very short reply. 0.78. What is the ratio of the Imports (BoP, current US$) in Cabo Verde in 2006 to that in 2008?
Provide a short and direct response. 0.68. What is the ratio of the Imports (BoP, current US$) of Kiribati in 2006 to that in 2008?
Your answer should be very brief. 0.76. What is the ratio of the Imports (BoP, current US$) in Peru in 2006 to that in 2008?
Make the answer very short. 0.53. What is the ratio of the Imports (BoP, current US$) of Cabo Verde in 2006 to that in 2009?
Offer a very short reply. 0.74. What is the ratio of the Imports (BoP, current US$) in Kiribati in 2006 to that in 2009?
Ensure brevity in your answer.  0.83. What is the ratio of the Imports (BoP, current US$) of Peru in 2006 to that in 2009?
Make the answer very short. 0.7. What is the ratio of the Imports (BoP, current US$) in OECD members in 2006 to that in 2010?
Provide a succinct answer. 0.87. What is the ratio of the Imports (BoP, current US$) of Cabo Verde in 2006 to that in 2010?
Provide a succinct answer. 0.72. What is the ratio of the Imports (BoP, current US$) in Kiribati in 2006 to that in 2010?
Provide a short and direct response. 0.77. What is the ratio of the Imports (BoP, current US$) in Peru in 2006 to that in 2010?
Give a very brief answer. 0.52. What is the ratio of the Imports (BoP, current US$) of OECD members in 2006 to that in 2011?
Your response must be concise. 0.74. What is the ratio of the Imports (BoP, current US$) in Cabo Verde in 2006 to that in 2011?
Provide a succinct answer. 0.59. What is the ratio of the Imports (BoP, current US$) in Kiribati in 2006 to that in 2011?
Keep it short and to the point. 0.62. What is the ratio of the Imports (BoP, current US$) of Peru in 2006 to that in 2011?
Provide a succinct answer. 0.42. What is the ratio of the Imports (BoP, current US$) in OECD members in 2006 to that in 2012?
Make the answer very short. 0.75. What is the ratio of the Imports (BoP, current US$) of Cabo Verde in 2006 to that in 2012?
Provide a short and direct response. 0.68. What is the ratio of the Imports (BoP, current US$) of Kiribati in 2006 to that in 2012?
Give a very brief answer. 0.53. What is the ratio of the Imports (BoP, current US$) of Peru in 2006 to that in 2012?
Ensure brevity in your answer.  0.37. What is the ratio of the Imports (BoP, current US$) of OECD members in 2007 to that in 2008?
Provide a short and direct response. 0.89. What is the ratio of the Imports (BoP, current US$) in Cabo Verde in 2007 to that in 2008?
Provide a short and direct response. 0.87. What is the ratio of the Imports (BoP, current US$) of Kiribati in 2007 to that in 2008?
Offer a very short reply. 0.92. What is the ratio of the Imports (BoP, current US$) of Peru in 2007 to that in 2008?
Ensure brevity in your answer.  0.7. What is the ratio of the Imports (BoP, current US$) of OECD members in 2007 to that in 2009?
Keep it short and to the point. 1.14. What is the ratio of the Imports (BoP, current US$) of Cabo Verde in 2007 to that in 2009?
Keep it short and to the point. 0.95. What is the ratio of the Imports (BoP, current US$) in Peru in 2007 to that in 2009?
Ensure brevity in your answer.  0.92. What is the ratio of the Imports (BoP, current US$) in OECD members in 2007 to that in 2010?
Make the answer very short. 0.99. What is the ratio of the Imports (BoP, current US$) of Cabo Verde in 2007 to that in 2010?
Keep it short and to the point. 0.93. What is the ratio of the Imports (BoP, current US$) of Kiribati in 2007 to that in 2010?
Ensure brevity in your answer.  0.92. What is the ratio of the Imports (BoP, current US$) of Peru in 2007 to that in 2010?
Give a very brief answer. 0.69. What is the ratio of the Imports (BoP, current US$) of OECD members in 2007 to that in 2011?
Your answer should be very brief. 0.84. What is the ratio of the Imports (BoP, current US$) in Cabo Verde in 2007 to that in 2011?
Your answer should be very brief. 0.75. What is the ratio of the Imports (BoP, current US$) in Kiribati in 2007 to that in 2011?
Your answer should be very brief. 0.74. What is the ratio of the Imports (BoP, current US$) of Peru in 2007 to that in 2011?
Offer a very short reply. 0.55. What is the ratio of the Imports (BoP, current US$) of OECD members in 2007 to that in 2012?
Give a very brief answer. 0.86. What is the ratio of the Imports (BoP, current US$) in Cabo Verde in 2007 to that in 2012?
Offer a terse response. 0.87. What is the ratio of the Imports (BoP, current US$) in Kiribati in 2007 to that in 2012?
Your answer should be compact. 0.64. What is the ratio of the Imports (BoP, current US$) of Peru in 2007 to that in 2012?
Your response must be concise. 0.49. What is the ratio of the Imports (BoP, current US$) of OECD members in 2008 to that in 2009?
Give a very brief answer. 1.29. What is the ratio of the Imports (BoP, current US$) in Cabo Verde in 2008 to that in 2009?
Give a very brief answer. 1.09. What is the ratio of the Imports (BoP, current US$) of Kiribati in 2008 to that in 2009?
Your answer should be very brief. 1.08. What is the ratio of the Imports (BoP, current US$) of Peru in 2008 to that in 2009?
Give a very brief answer. 1.32. What is the ratio of the Imports (BoP, current US$) of OECD members in 2008 to that in 2010?
Offer a very short reply. 1.11. What is the ratio of the Imports (BoP, current US$) of Cabo Verde in 2008 to that in 2010?
Offer a terse response. 1.06. What is the ratio of the Imports (BoP, current US$) of Peru in 2008 to that in 2010?
Give a very brief answer. 0.98. What is the ratio of the Imports (BoP, current US$) of OECD members in 2008 to that in 2011?
Provide a succinct answer. 0.95. What is the ratio of the Imports (BoP, current US$) in Cabo Verde in 2008 to that in 2011?
Provide a succinct answer. 0.86. What is the ratio of the Imports (BoP, current US$) of Kiribati in 2008 to that in 2011?
Your response must be concise. 0.81. What is the ratio of the Imports (BoP, current US$) in Peru in 2008 to that in 2011?
Your response must be concise. 0.79. What is the ratio of the Imports (BoP, current US$) in OECD members in 2008 to that in 2012?
Provide a short and direct response. 0.96. What is the ratio of the Imports (BoP, current US$) of Kiribati in 2008 to that in 2012?
Your answer should be very brief. 0.7. What is the ratio of the Imports (BoP, current US$) of Peru in 2008 to that in 2012?
Your response must be concise. 0.71. What is the ratio of the Imports (BoP, current US$) in OECD members in 2009 to that in 2010?
Offer a terse response. 0.87. What is the ratio of the Imports (BoP, current US$) in Cabo Verde in 2009 to that in 2010?
Your response must be concise. 0.97. What is the ratio of the Imports (BoP, current US$) in Kiribati in 2009 to that in 2010?
Give a very brief answer. 0.92. What is the ratio of the Imports (BoP, current US$) in Peru in 2009 to that in 2010?
Ensure brevity in your answer.  0.74. What is the ratio of the Imports (BoP, current US$) of OECD members in 2009 to that in 2011?
Your answer should be very brief. 0.74. What is the ratio of the Imports (BoP, current US$) of Cabo Verde in 2009 to that in 2011?
Offer a very short reply. 0.79. What is the ratio of the Imports (BoP, current US$) in Kiribati in 2009 to that in 2011?
Your answer should be compact. 0.74. What is the ratio of the Imports (BoP, current US$) of Peru in 2009 to that in 2011?
Your answer should be very brief. 0.6. What is the ratio of the Imports (BoP, current US$) of OECD members in 2009 to that in 2012?
Provide a short and direct response. 0.75. What is the ratio of the Imports (BoP, current US$) of Cabo Verde in 2009 to that in 2012?
Offer a very short reply. 0.91. What is the ratio of the Imports (BoP, current US$) in Kiribati in 2009 to that in 2012?
Keep it short and to the point. 0.64. What is the ratio of the Imports (BoP, current US$) in Peru in 2009 to that in 2012?
Your response must be concise. 0.54. What is the ratio of the Imports (BoP, current US$) of OECD members in 2010 to that in 2011?
Ensure brevity in your answer.  0.85. What is the ratio of the Imports (BoP, current US$) of Cabo Verde in 2010 to that in 2011?
Provide a short and direct response. 0.81. What is the ratio of the Imports (BoP, current US$) in Kiribati in 2010 to that in 2011?
Ensure brevity in your answer.  0.81. What is the ratio of the Imports (BoP, current US$) in Peru in 2010 to that in 2011?
Offer a very short reply. 0.8. What is the ratio of the Imports (BoP, current US$) in OECD members in 2010 to that in 2012?
Provide a short and direct response. 0.87. What is the ratio of the Imports (BoP, current US$) of Cabo Verde in 2010 to that in 2012?
Ensure brevity in your answer.  0.94. What is the ratio of the Imports (BoP, current US$) of Kiribati in 2010 to that in 2012?
Your answer should be very brief. 0.7. What is the ratio of the Imports (BoP, current US$) in Peru in 2010 to that in 2012?
Keep it short and to the point. 0.72. What is the ratio of the Imports (BoP, current US$) in OECD members in 2011 to that in 2012?
Ensure brevity in your answer.  1.01. What is the ratio of the Imports (BoP, current US$) of Cabo Verde in 2011 to that in 2012?
Offer a very short reply. 1.16. What is the ratio of the Imports (BoP, current US$) in Kiribati in 2011 to that in 2012?
Your answer should be compact. 0.87. What is the ratio of the Imports (BoP, current US$) of Peru in 2011 to that in 2012?
Your answer should be very brief. 0.9. What is the difference between the highest and the second highest Imports (BoP, current US$) in OECD members?
Your answer should be very brief. 2.02e+11. What is the difference between the highest and the second highest Imports (BoP, current US$) in Cabo Verde?
Offer a terse response. 1.86e+08. What is the difference between the highest and the second highest Imports (BoP, current US$) of Kiribati?
Offer a terse response. 2.43e+07. What is the difference between the highest and the second highest Imports (BoP, current US$) in Peru?
Your answer should be compact. 4.77e+09. What is the difference between the highest and the lowest Imports (BoP, current US$) in OECD members?
Offer a very short reply. 3.59e+12. What is the difference between the highest and the lowest Imports (BoP, current US$) of Cabo Verde?
Make the answer very short. 5.70e+08. What is the difference between the highest and the lowest Imports (BoP, current US$) in Kiribati?
Keep it short and to the point. 8.41e+07. What is the difference between the highest and the lowest Imports (BoP, current US$) in Peru?
Offer a terse response. 2.99e+1. 